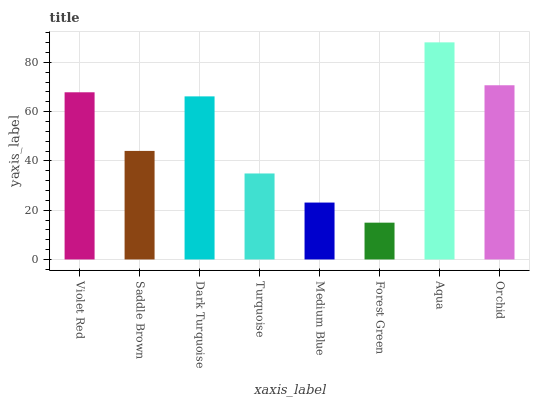Is Forest Green the minimum?
Answer yes or no. Yes. Is Aqua the maximum?
Answer yes or no. Yes. Is Saddle Brown the minimum?
Answer yes or no. No. Is Saddle Brown the maximum?
Answer yes or no. No. Is Violet Red greater than Saddle Brown?
Answer yes or no. Yes. Is Saddle Brown less than Violet Red?
Answer yes or no. Yes. Is Saddle Brown greater than Violet Red?
Answer yes or no. No. Is Violet Red less than Saddle Brown?
Answer yes or no. No. Is Dark Turquoise the high median?
Answer yes or no. Yes. Is Saddle Brown the low median?
Answer yes or no. Yes. Is Saddle Brown the high median?
Answer yes or no. No. Is Violet Red the low median?
Answer yes or no. No. 